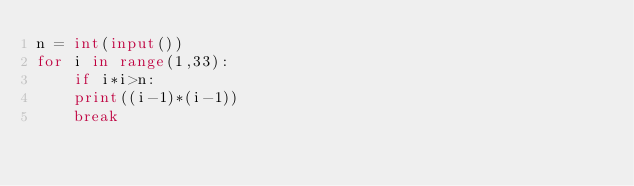<code> <loc_0><loc_0><loc_500><loc_500><_Python_>n = int(input())
for i in range(1,33):
    if i*i>n:
    print((i-1)*(i-1))
    break</code> 